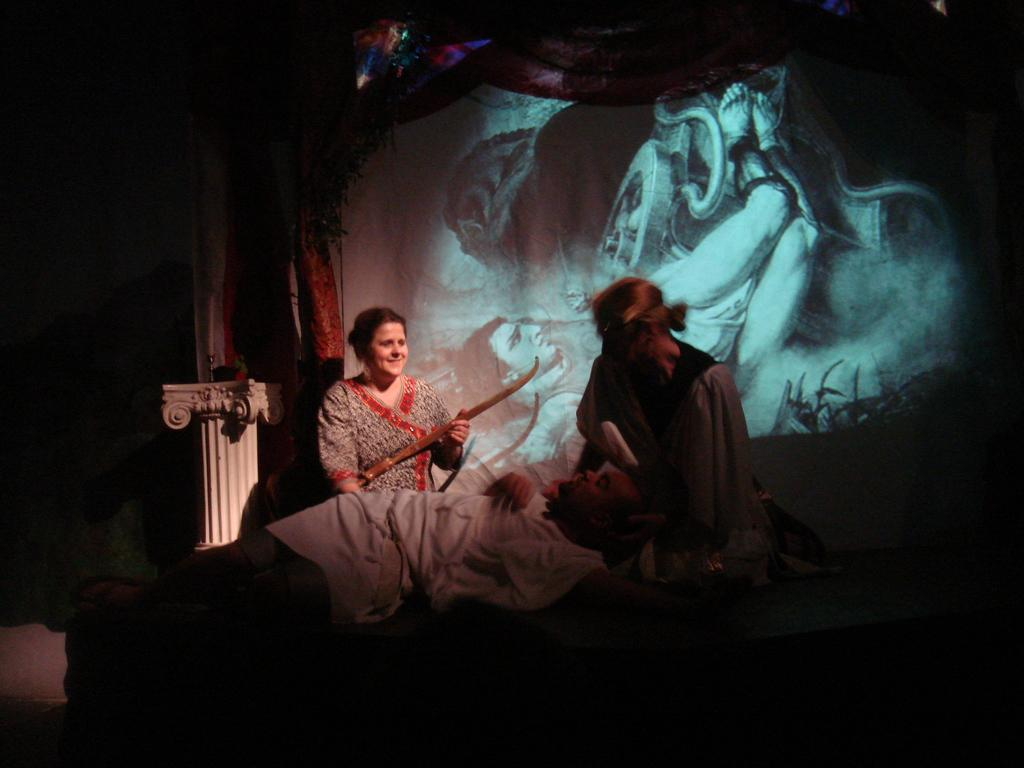What are the people in the image wearing? The persons in the image are wearing clothes. What can be seen in the middle of the image? There is a screen in the middle of the image. What type of window treatment is present at the top of the image? There are curtains at the top of the image. What type of silk fabric is draped over the trees in the image? There are no trees or silk fabric present in the image. How many cellars can be seen in the image? There are no cellars visible in the image. 